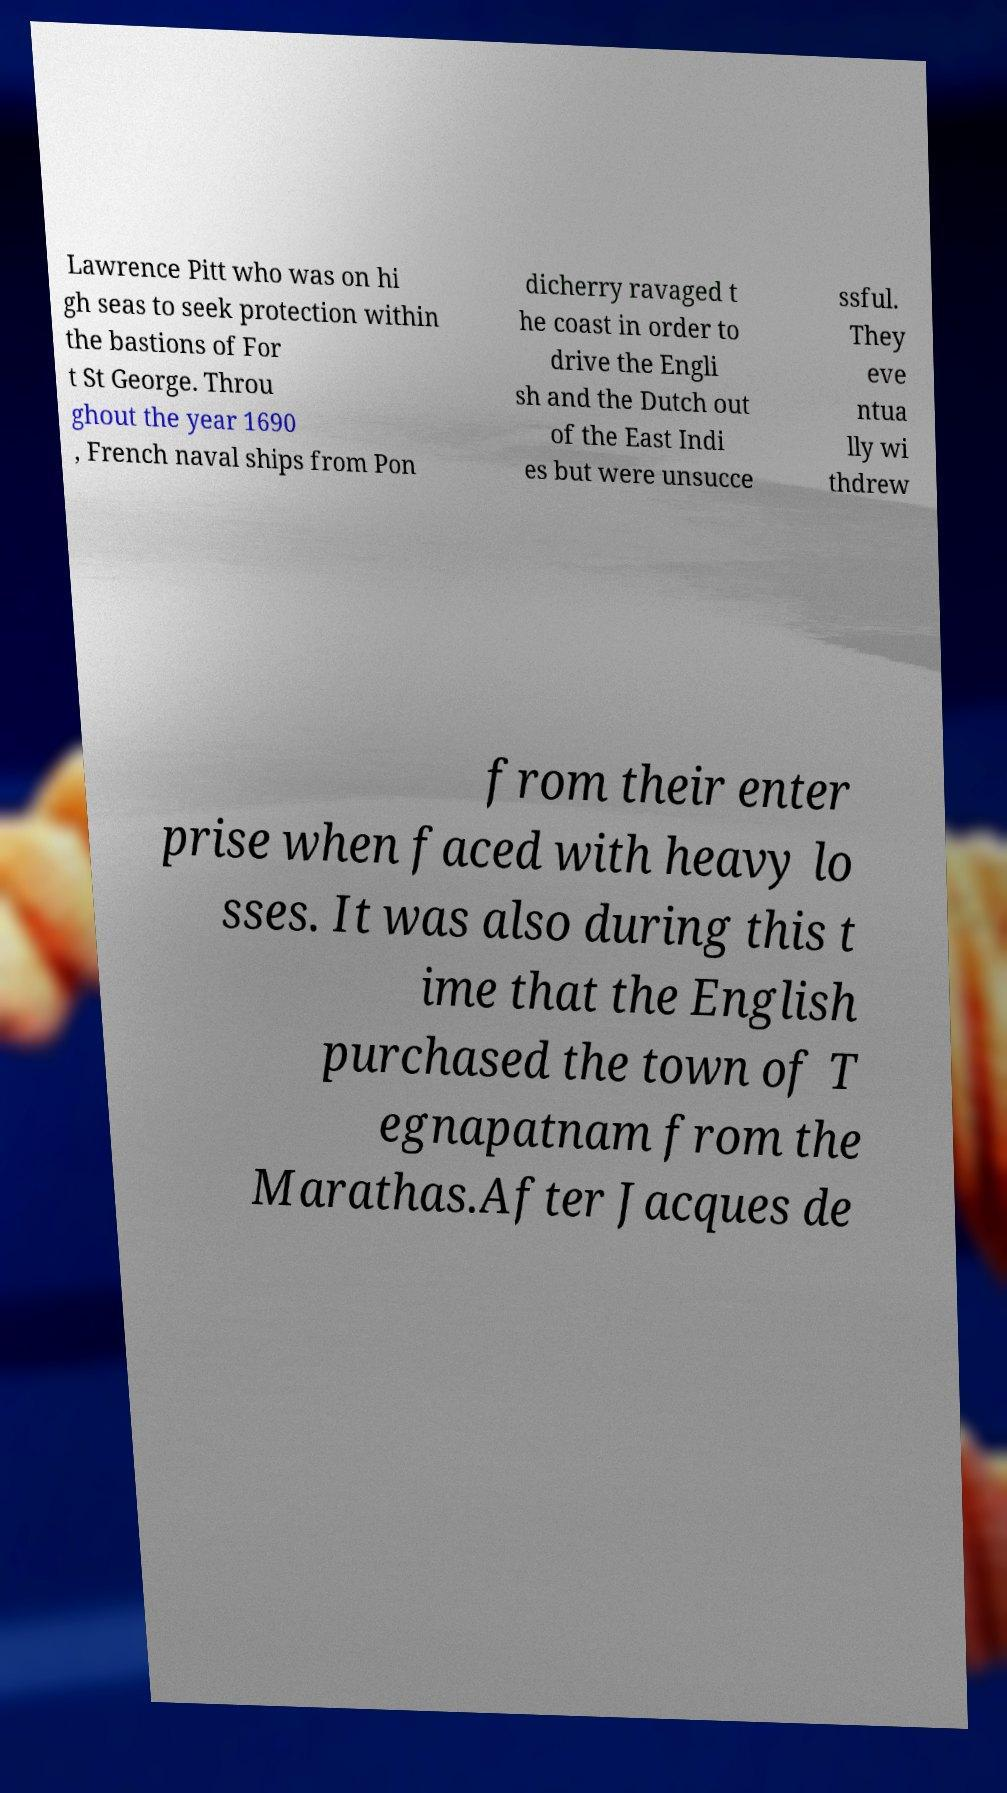There's text embedded in this image that I need extracted. Can you transcribe it verbatim? Lawrence Pitt who was on hi gh seas to seek protection within the bastions of For t St George. Throu ghout the year 1690 , French naval ships from Pon dicherry ravaged t he coast in order to drive the Engli sh and the Dutch out of the East Indi es but were unsucce ssful. They eve ntua lly wi thdrew from their enter prise when faced with heavy lo sses. It was also during this t ime that the English purchased the town of T egnapatnam from the Marathas.After Jacques de 